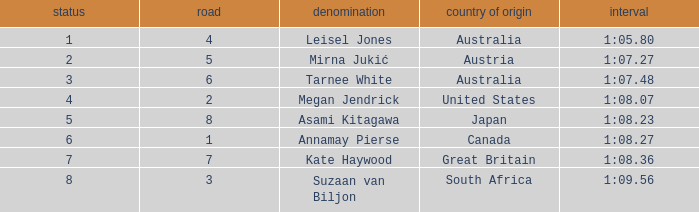What is the Nationality of the Swimmer in Lane 4 or larger with a Rank of 5 or more? Great Britain. 